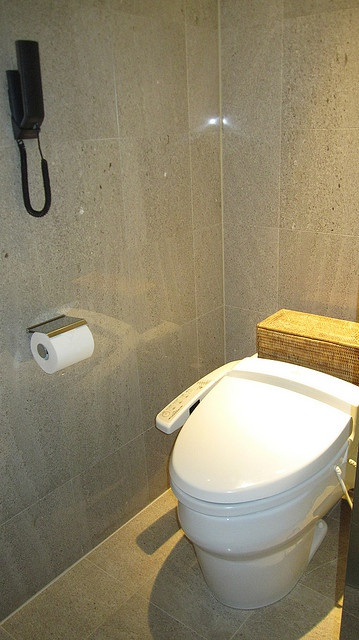Describe the objects in this image and their specific colors. I can see a toilet in gray, ivory, and darkgray tones in this image. 